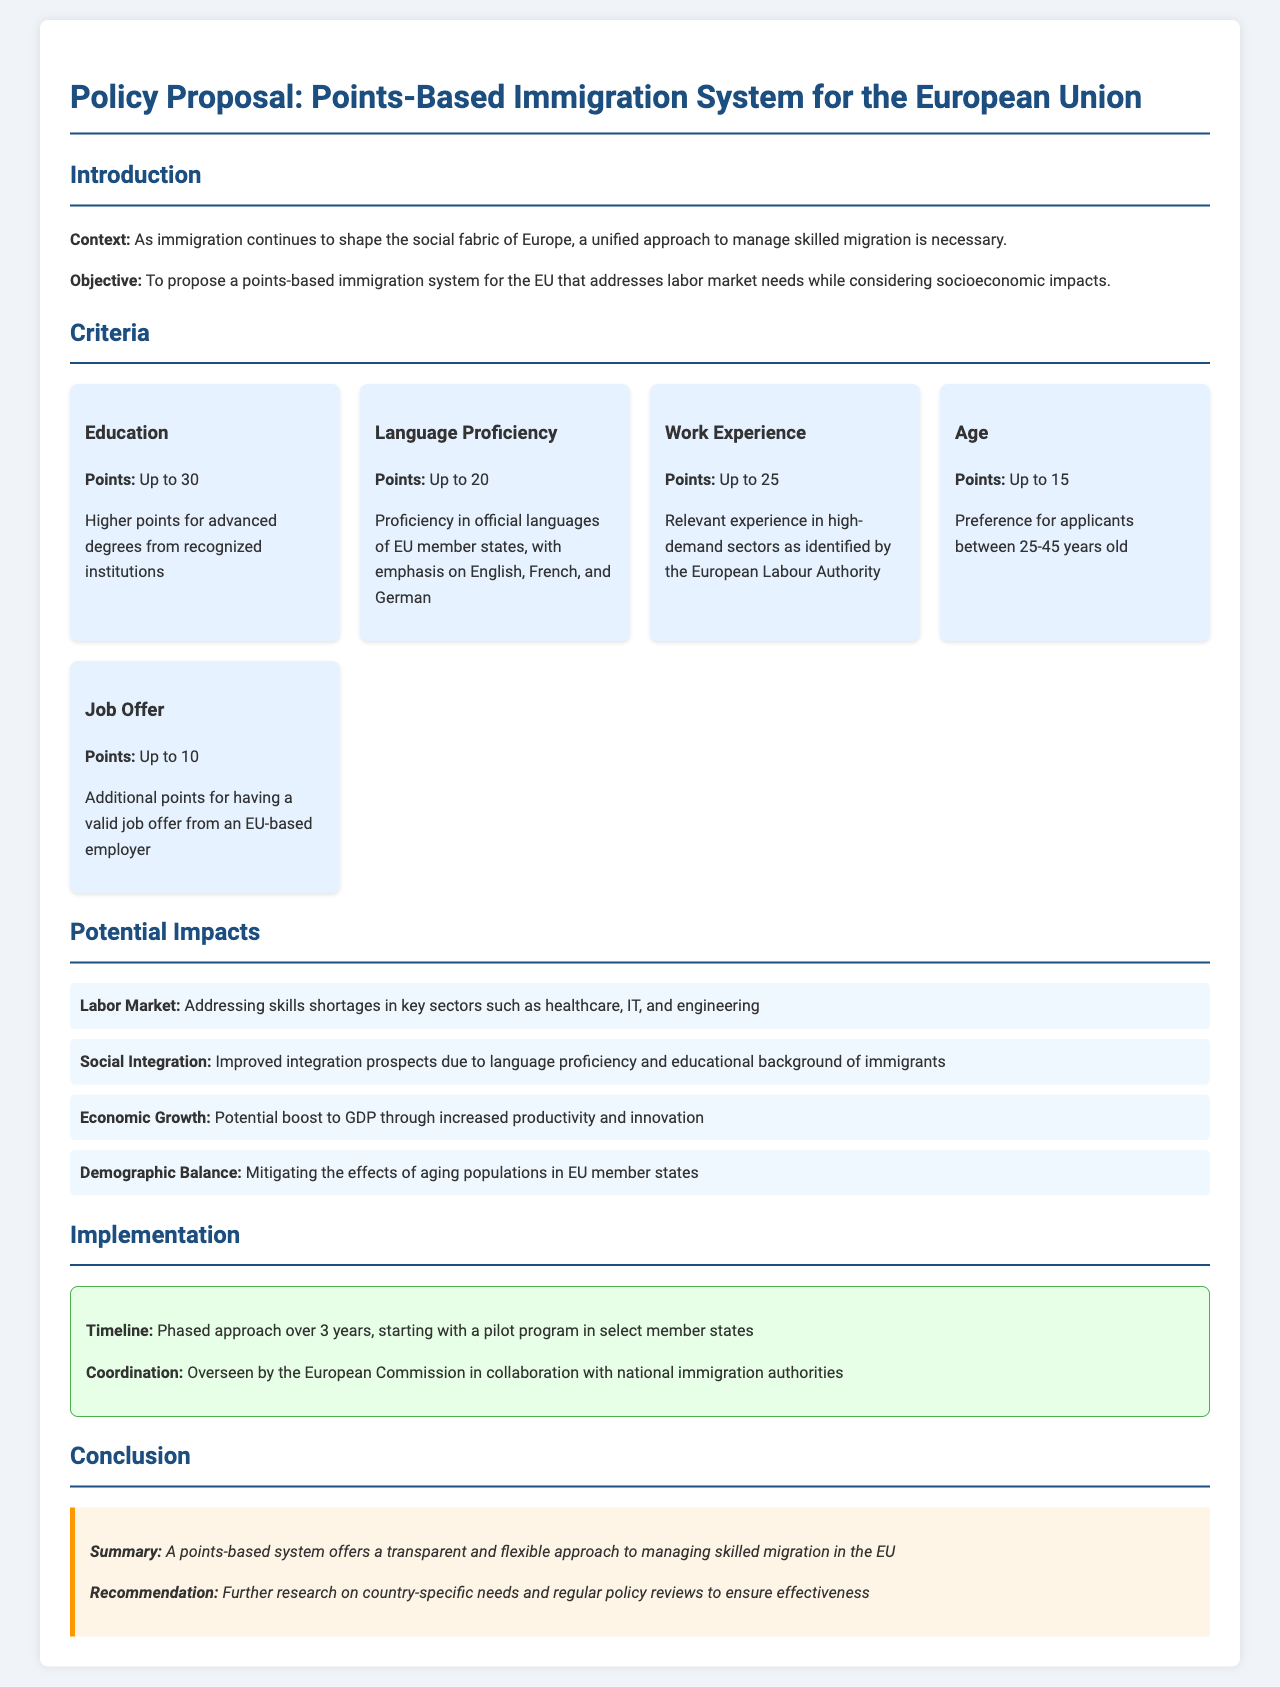what is the maximum number of points for education? The document specifies that the maximum points for education are up to 30.
Answer: 30 how many points can be earned for language proficiency? The proposal states that applicants can earn up to 20 points for language proficiency.
Answer: 20 what age range is preferred for applicants? The document indicates a preference for applicants between 25-45 years old.
Answer: 25-45 which sector is mentioned as having a skills shortage? The proposal refers to key sectors such as healthcare, IT, and engineering as having skills shortages.
Answer: healthcare, IT, and engineering what is the duration of the proposed implementation timeline? The document outlines a phased approach over 3 years for implementation.
Answer: 3 years what is the main objective of the proposed system? The main objective is to propose a points-based immigration system that addresses labor market needs while considering socioeconomic impacts.
Answer: address labor market needs which entity oversees the coordination of the proposed system? The document mentions that the coordination will be overseen by the European Commission.
Answer: European Commission what is the additional points provided for having a valid job offer? The proposal grants up to 10 additional points for having a valid job offer from an EU-based employer.
Answer: 10 what does the summary highlight about the points-based system? The summary states that a points-based system offers a transparent and flexible approach to managing skilled migration in the EU.
Answer: transparent and flexible 